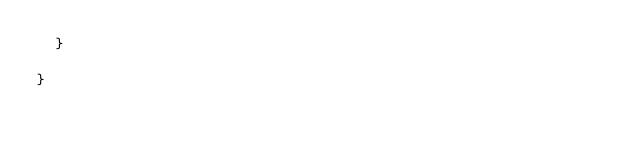Convert code to text. <code><loc_0><loc_0><loc_500><loc_500><_Scala_>  }

}
</code> 